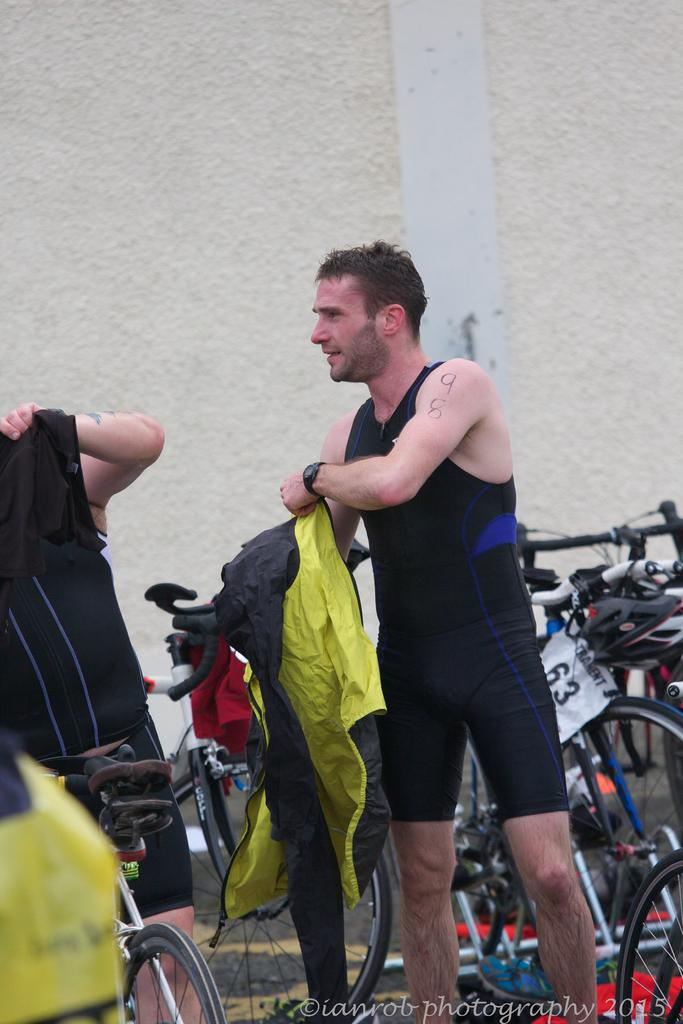How many people are present in the image? There are two people standing in the image. What is one of the people holding? One person is holding a jacket in the image. What can be seen behind the people? There are bicycles and a wall behind the people in the image. Is there any additional information about the image itself? Yes, there is a watermark on the image. What type of pain is the person experiencing in the image? There is no indication of pain in the image; both people appear to be standing comfortably. How many bells can be seen hanging from the wall in the image? There are no bells visible in the image; the wall is behind the people and bicycles. 